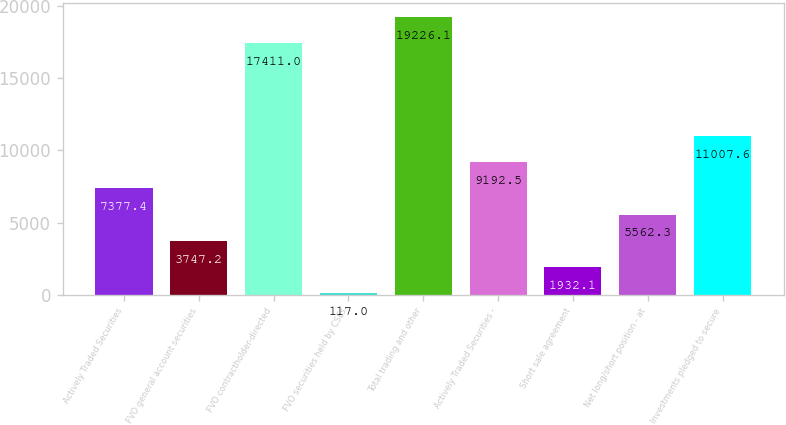Convert chart. <chart><loc_0><loc_0><loc_500><loc_500><bar_chart><fcel>Actively Traded Securities<fcel>FVO general account securities<fcel>FVO contractholder-directed<fcel>FVO securities held by CSEs<fcel>Total trading and other<fcel>Actively Traded Securities -<fcel>Short sale agreement<fcel>Net long/short position - at<fcel>Investments pledged to secure<nl><fcel>7377.4<fcel>3747.2<fcel>17411<fcel>117<fcel>19226.1<fcel>9192.5<fcel>1932.1<fcel>5562.3<fcel>11007.6<nl></chart> 